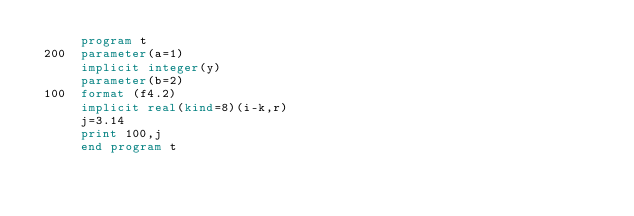<code> <loc_0><loc_0><loc_500><loc_500><_FORTRAN_>      program t
 200  parameter(a=1)
      implicit integer(y)
      parameter(b=2)
 100  format (f4.2)
      implicit real(kind=8)(i-k,r)
      j=3.14
      print 100,j
      end program t
</code> 